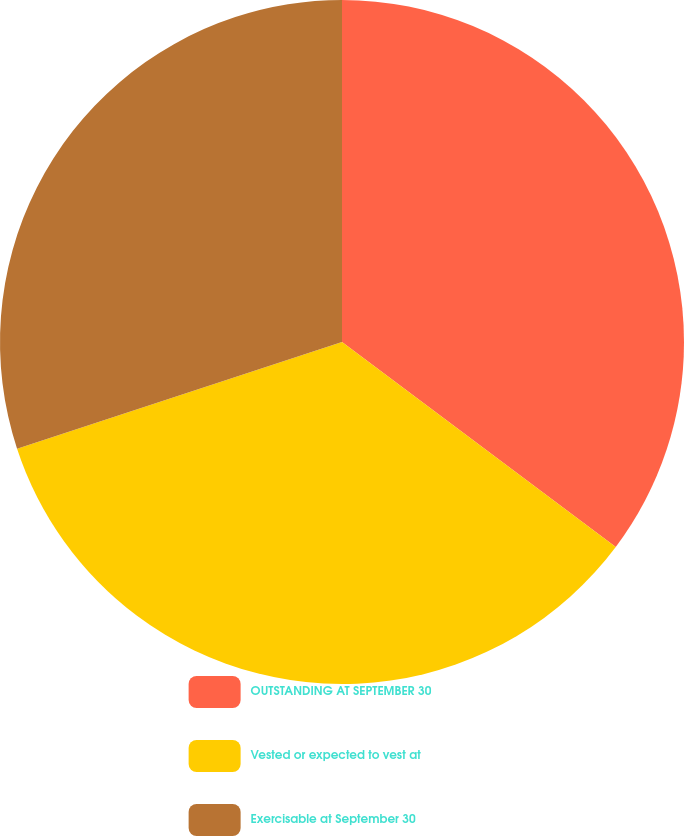<chart> <loc_0><loc_0><loc_500><loc_500><pie_chart><fcel>OUTSTANDING AT SEPTEMBER 30<fcel>Vested or expected to vest at<fcel>Exercisable at September 30<nl><fcel>35.23%<fcel>34.72%<fcel>30.05%<nl></chart> 